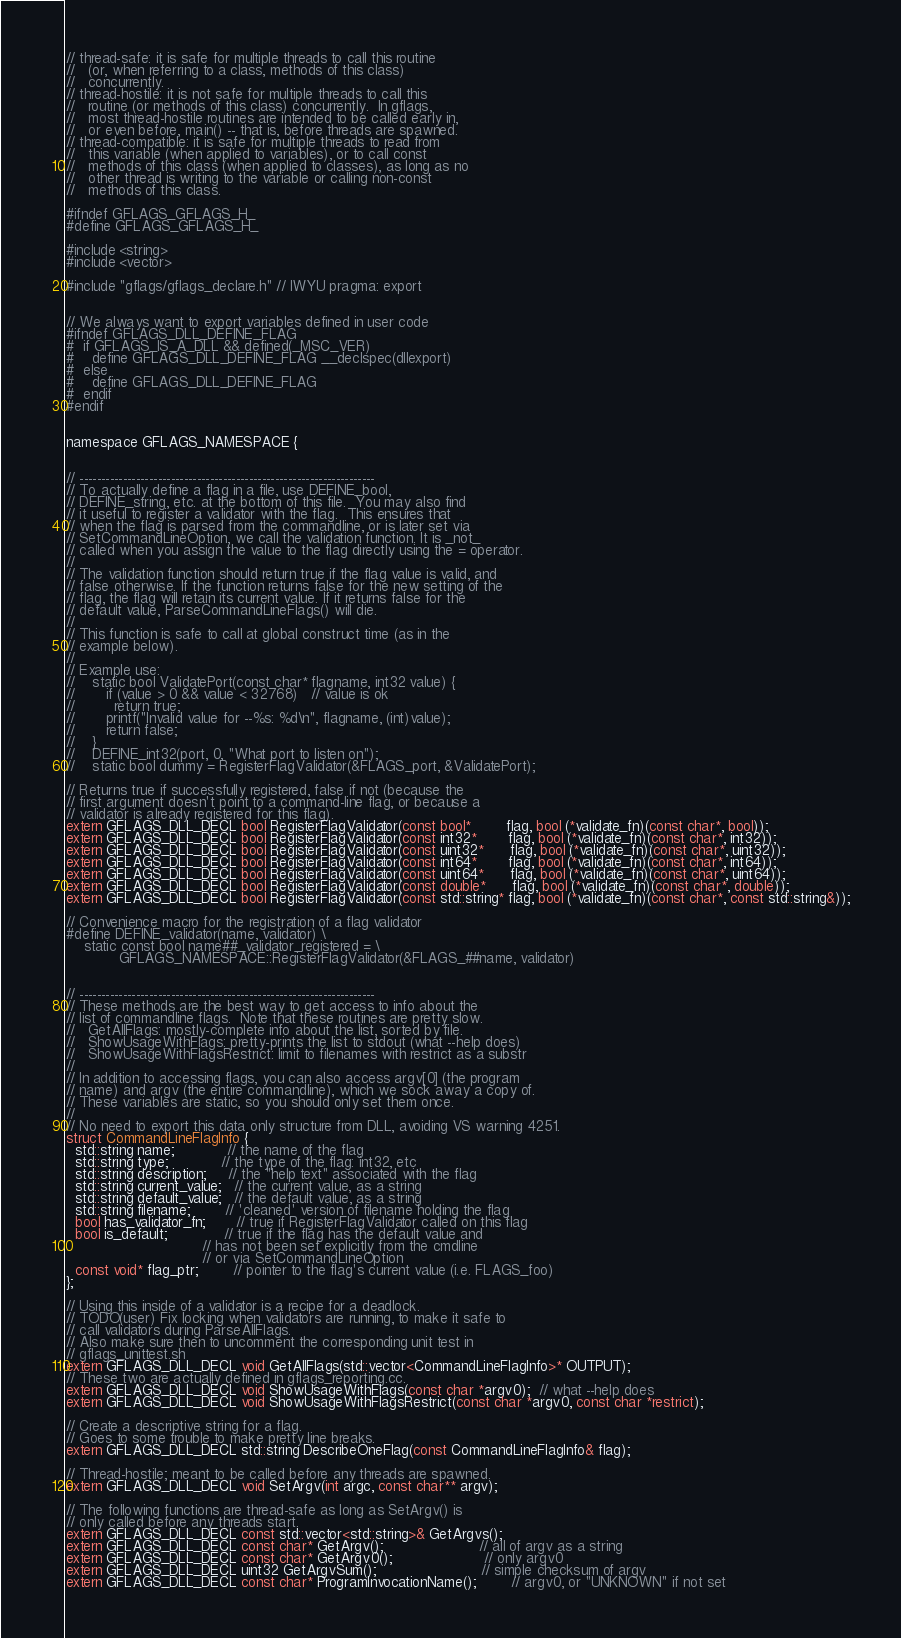<code> <loc_0><loc_0><loc_500><loc_500><_C_>// thread-safe: it is safe for multiple threads to call this routine
//   (or, when referring to a class, methods of this class)
//   concurrently.
// thread-hostile: it is not safe for multiple threads to call this
//   routine (or methods of this class) concurrently.  In gflags,
//   most thread-hostile routines are intended to be called early in,
//   or even before, main() -- that is, before threads are spawned.
// thread-compatible: it is safe for multiple threads to read from
//   this variable (when applied to variables), or to call const
//   methods of this class (when applied to classes), as long as no
//   other thread is writing to the variable or calling non-const
//   methods of this class.

#ifndef GFLAGS_GFLAGS_H_
#define GFLAGS_GFLAGS_H_

#include <string>
#include <vector>

#include "gflags/gflags_declare.h" // IWYU pragma: export


// We always want to export variables defined in user code
#ifndef GFLAGS_DLL_DEFINE_FLAG
#  if GFLAGS_IS_A_DLL && defined(_MSC_VER)
#    define GFLAGS_DLL_DEFINE_FLAG __declspec(dllexport)
#  else
#    define GFLAGS_DLL_DEFINE_FLAG
#  endif
#endif


namespace GFLAGS_NAMESPACE {


// --------------------------------------------------------------------
// To actually define a flag in a file, use DEFINE_bool,
// DEFINE_string, etc. at the bottom of this file.  You may also find
// it useful to register a validator with the flag.  This ensures that
// when the flag is parsed from the commandline, or is later set via
// SetCommandLineOption, we call the validation function. It is _not_
// called when you assign the value to the flag directly using the = operator.
//
// The validation function should return true if the flag value is valid, and
// false otherwise. If the function returns false for the new setting of the
// flag, the flag will retain its current value. If it returns false for the
// default value, ParseCommandLineFlags() will die.
//
// This function is safe to call at global construct time (as in the
// example below).
//
// Example use:
//    static bool ValidatePort(const char* flagname, int32 value) {
//       if (value > 0 && value < 32768)   // value is ok
//         return true;
//       printf("Invalid value for --%s: %d\n", flagname, (int)value);
//       return false;
//    }
//    DEFINE_int32(port, 0, "What port to listen on");
//    static bool dummy = RegisterFlagValidator(&FLAGS_port, &ValidatePort);

// Returns true if successfully registered, false if not (because the
// first argument doesn't point to a command-line flag, or because a
// validator is already registered for this flag).
extern GFLAGS_DLL_DECL bool RegisterFlagValidator(const bool*        flag, bool (*validate_fn)(const char*, bool));
extern GFLAGS_DLL_DECL bool RegisterFlagValidator(const int32*       flag, bool (*validate_fn)(const char*, int32));
extern GFLAGS_DLL_DECL bool RegisterFlagValidator(const uint32*      flag, bool (*validate_fn)(const char*, uint32));
extern GFLAGS_DLL_DECL bool RegisterFlagValidator(const int64*       flag, bool (*validate_fn)(const char*, int64));
extern GFLAGS_DLL_DECL bool RegisterFlagValidator(const uint64*      flag, bool (*validate_fn)(const char*, uint64));
extern GFLAGS_DLL_DECL bool RegisterFlagValidator(const double*      flag, bool (*validate_fn)(const char*, double));
extern GFLAGS_DLL_DECL bool RegisterFlagValidator(const std::string* flag, bool (*validate_fn)(const char*, const std::string&));

// Convenience macro for the registration of a flag validator
#define DEFINE_validator(name, validator) \
    static const bool name##_validator_registered = \
            GFLAGS_NAMESPACE::RegisterFlagValidator(&FLAGS_##name, validator)


// --------------------------------------------------------------------
// These methods are the best way to get access to info about the
// list of commandline flags.  Note that these routines are pretty slow.
//   GetAllFlags: mostly-complete info about the list, sorted by file.
//   ShowUsageWithFlags: pretty-prints the list to stdout (what --help does)
//   ShowUsageWithFlagsRestrict: limit to filenames with restrict as a substr
//
// In addition to accessing flags, you can also access argv[0] (the program
// name) and argv (the entire commandline), which we sock away a copy of.
// These variables are static, so you should only set them once.
//
// No need to export this data only structure from DLL, avoiding VS warning 4251.
struct CommandLineFlagInfo {
  std::string name;            // the name of the flag
  std::string type;            // the type of the flag: int32, etc
  std::string description;     // the "help text" associated with the flag
  std::string current_value;   // the current value, as a string
  std::string default_value;   // the default value, as a string
  std::string filename;        // 'cleaned' version of filename holding the flag
  bool has_validator_fn;       // true if RegisterFlagValidator called on this flag
  bool is_default;             // true if the flag has the default value and
                               // has not been set explicitly from the cmdline
                               // or via SetCommandLineOption
  const void* flag_ptr;        // pointer to the flag's current value (i.e. FLAGS_foo)
};

// Using this inside of a validator is a recipe for a deadlock.
// TODO(user) Fix locking when validators are running, to make it safe to
// call validators during ParseAllFlags.
// Also make sure then to uncomment the corresponding unit test in
// gflags_unittest.sh
extern GFLAGS_DLL_DECL void GetAllFlags(std::vector<CommandLineFlagInfo>* OUTPUT);
// These two are actually defined in gflags_reporting.cc.
extern GFLAGS_DLL_DECL void ShowUsageWithFlags(const char *argv0);  // what --help does
extern GFLAGS_DLL_DECL void ShowUsageWithFlagsRestrict(const char *argv0, const char *restrict);

// Create a descriptive string for a flag.
// Goes to some trouble to make pretty line breaks.
extern GFLAGS_DLL_DECL std::string DescribeOneFlag(const CommandLineFlagInfo& flag);

// Thread-hostile; meant to be called before any threads are spawned.
extern GFLAGS_DLL_DECL void SetArgv(int argc, const char** argv);

// The following functions are thread-safe as long as SetArgv() is
// only called before any threads start.
extern GFLAGS_DLL_DECL const std::vector<std::string>& GetArgvs();
extern GFLAGS_DLL_DECL const char* GetArgv();                      // all of argv as a string
extern GFLAGS_DLL_DECL const char* GetArgv0();                     // only argv0
extern GFLAGS_DLL_DECL uint32 GetArgvSum();                        // simple checksum of argv
extern GFLAGS_DLL_DECL const char* ProgramInvocationName();        // argv0, or "UNKNOWN" if not set</code> 